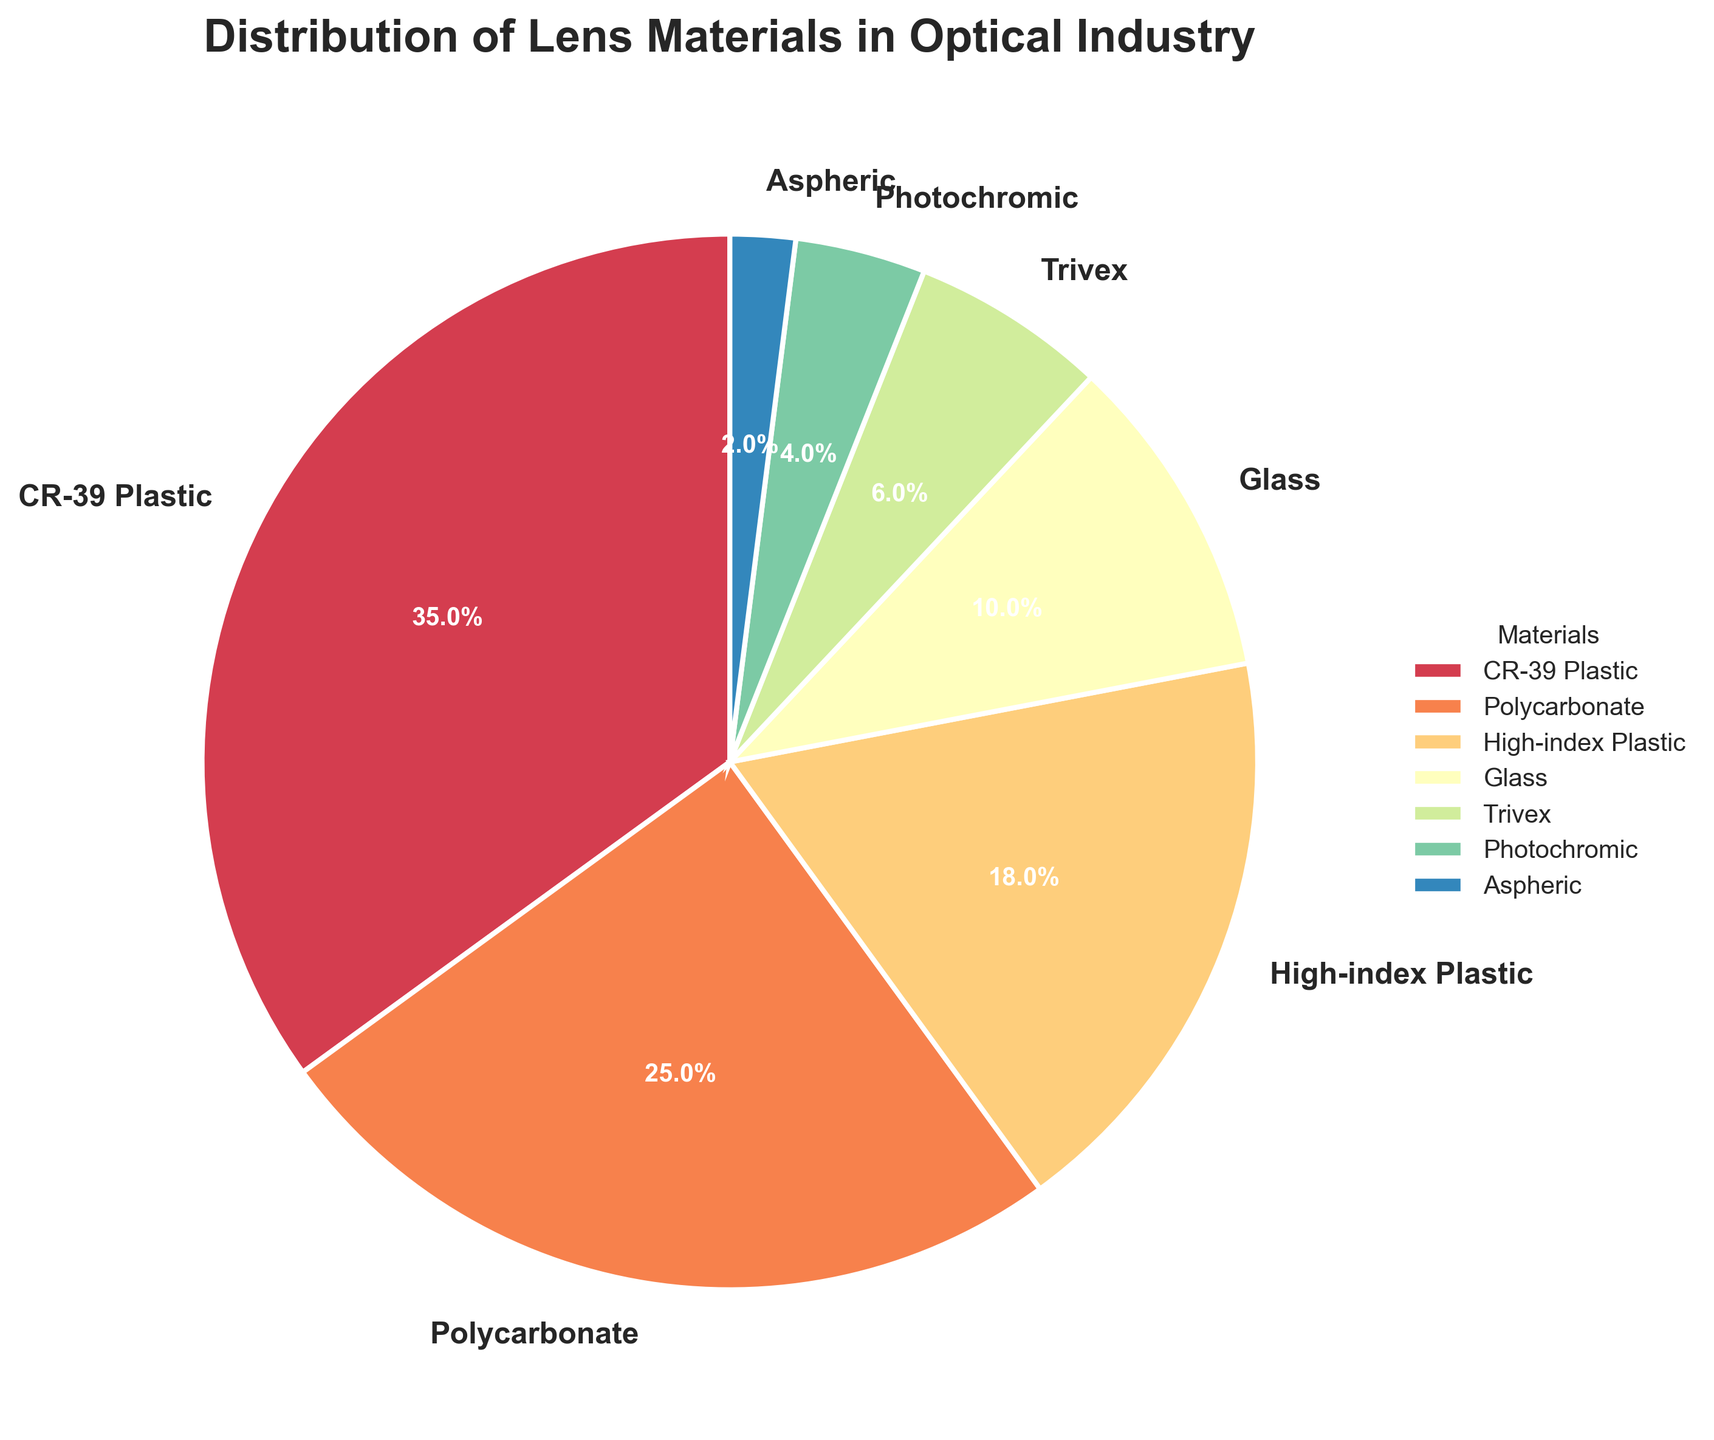Which material has the highest percentage in the pie chart? The material with the highest sector area and the label with the highest percentage value is CR-39 Plastic with 35%.
Answer: CR-39 Plastic Which two materials together make up more than half of the total distribution? By looking at the largest sectors, CR-39 Plastic (35%) and Polycarbonate (25%) together make up 60% which is more than half.
Answer: CR-39 Plastic and Polycarbonate What is the combined percentage of High-index Plastic and Trivex? High-index Plastic is 18% and Trivex is 6%. Adding them together gives 18% + 6% = 24%.
Answer: 24% Which material contributes the least percentage to the distribution? The smallest wedge in the pie chart represents Aspheric with a label of 2%.
Answer: Aspheric Is the percentage of Polycarbonate higher or lower than the percentage of Glass? By comparing the labels, Polycarbonate has 25% and Glass has 10%. 25% is higher than 10%.
Answer: Higher How much more percentage does CR-39 Plastic contribute compared to Photochromic? CR-39 Plastic contributes 35% and Photochromic contributes 4%. The difference is 35% - 4% = 31%.
Answer: 31% What is the total percentage of materials that individually contribute less than 10%? Materials with less than 10% are Glass (10%), Trivex (6%), Photochromic (4%), and Aspheric (2%). Adding these gives: 10% + 6% + 4% + 2% = 22%.
Answer: 22% Which material is represented by the fourth-largest sector in the pie chart? The fourth-largest sector corresponds to Glass with 10% after CR-39 Plastic, Polycarbonate, and High-index Plastic.
Answer: Glass Are there more materials with percentages greater than or equal to 10% or less than 10%? Materials with ≥10%: CR-39 Plastic, Polycarbonate, High-index Plastic, and Glass (4 materials). Materials with <10%: Trivex, Photochromic, and Aspheric (3 materials). 4 is greater than 3.
Answer: Greater than or equal to 10% What proportion of the total is made up by both CR-39 Plastic and High-index Plastic together? CR-39 Plastic is 35% and High-index Plastic is 18%. Adding them: 35% + 18% = 53%, which is more than half of the total.
Answer: 53% 